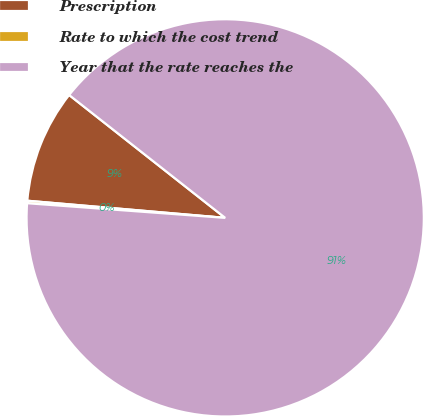Convert chart. <chart><loc_0><loc_0><loc_500><loc_500><pie_chart><fcel>Prescription<fcel>Rate to which the cost trend<fcel>Year that the rate reaches the<nl><fcel>9.24%<fcel>0.2%<fcel>90.56%<nl></chart> 